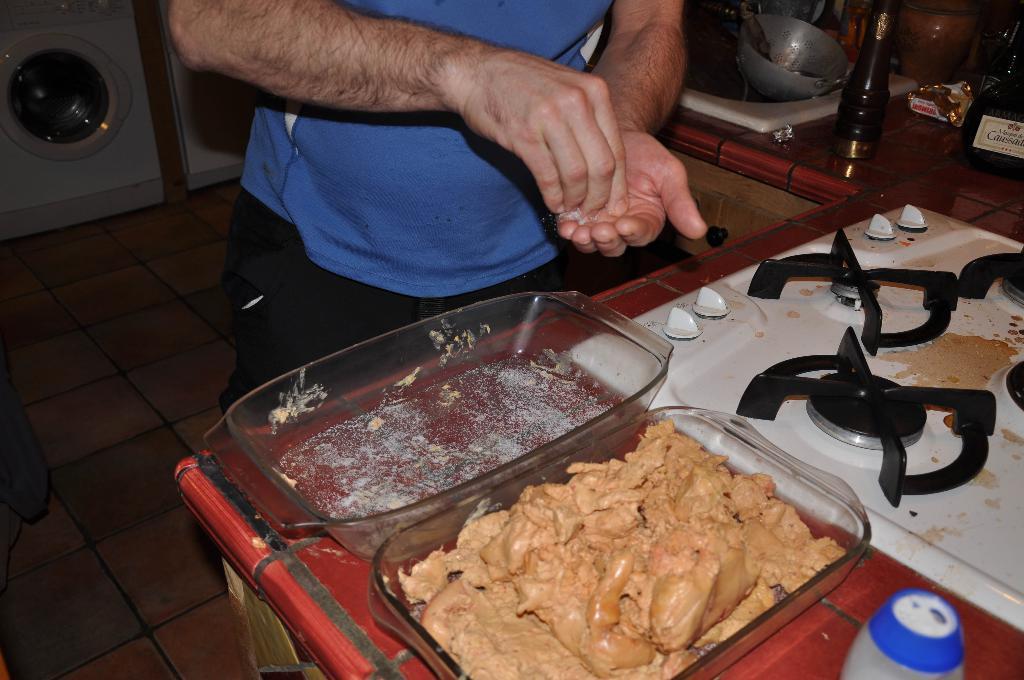Could you give a brief overview of what you see in this image? In this picture we can see some food items in the tray and the trays are on the kitchen cabinet. On the right side of the trays there is the stove, a bowl, bottle and some objects. Behind the trays there is a person in the blue t shirt is standing on the floor. Behind the person, it looks like a washing machine. 